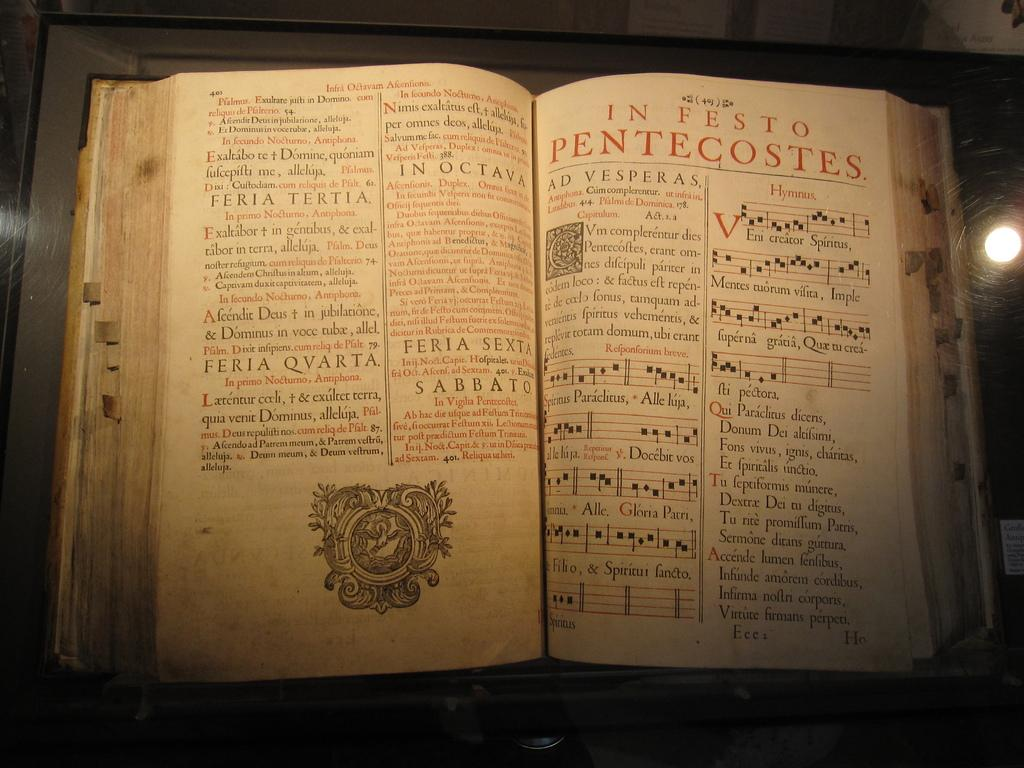<image>
Give a short and clear explanation of the subsequent image. the word vesperas can be found in the book 